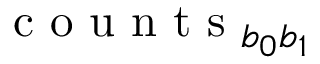<formula> <loc_0><loc_0><loc_500><loc_500>c o u n t s _ { b _ { 0 } b _ { 1 } }</formula> 